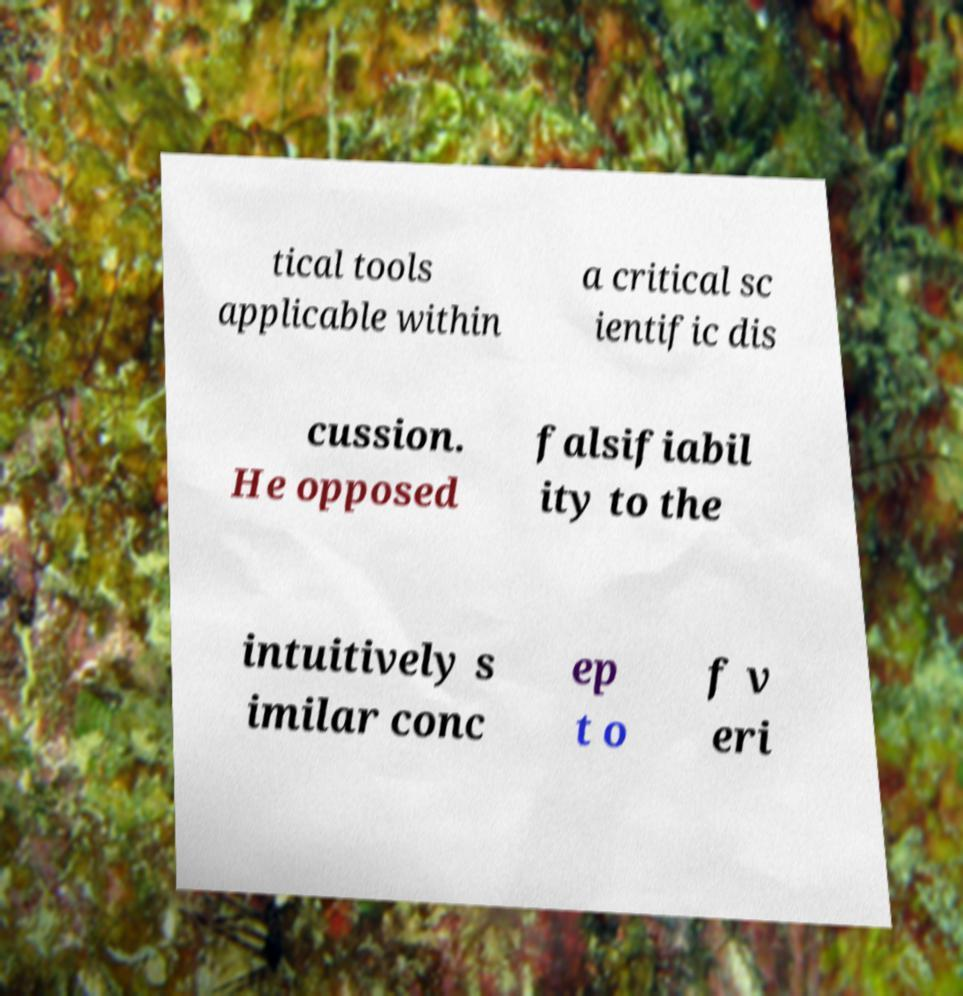Please read and relay the text visible in this image. What does it say? tical tools applicable within a critical sc ientific dis cussion. He opposed falsifiabil ity to the intuitively s imilar conc ep t o f v eri 